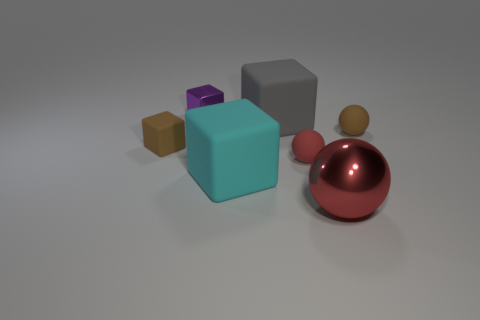Can you describe the textures visible on the different objects in the image? Certainly! The objects display a variety of textures: the teal cube and the gray cube have smooth and slightly reflective surfaces; the brown and tiny purple objects exhibit more matte finishes, indicating possibly soft or rubber-like materials. The red sphere has a highly reflective glossy surface that suggests it could be made of polished metal or plastic. Do these textures contribute to any thematic elements in the image? Yes, the contrasting textures enhance the visual diversity and add depth to the composition. They might suggest a theme of diversity or contrast, illustrating how different elements can coexist harmoniously. This thematic observation could reflect on broader concepts like diversity in unity or the balance between different entities. 